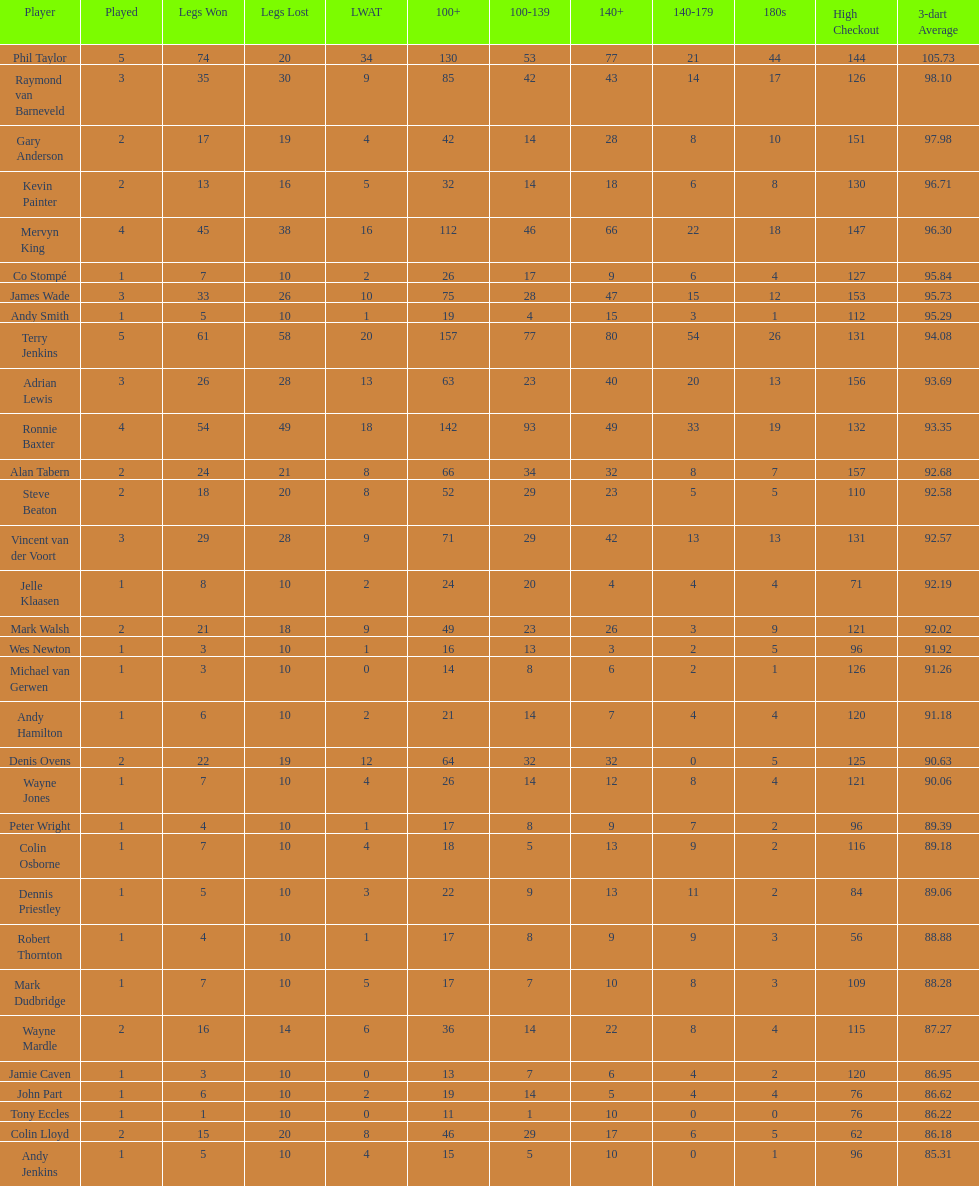How many players in the 2009 world matchplay won at least 30 legs? 6. 